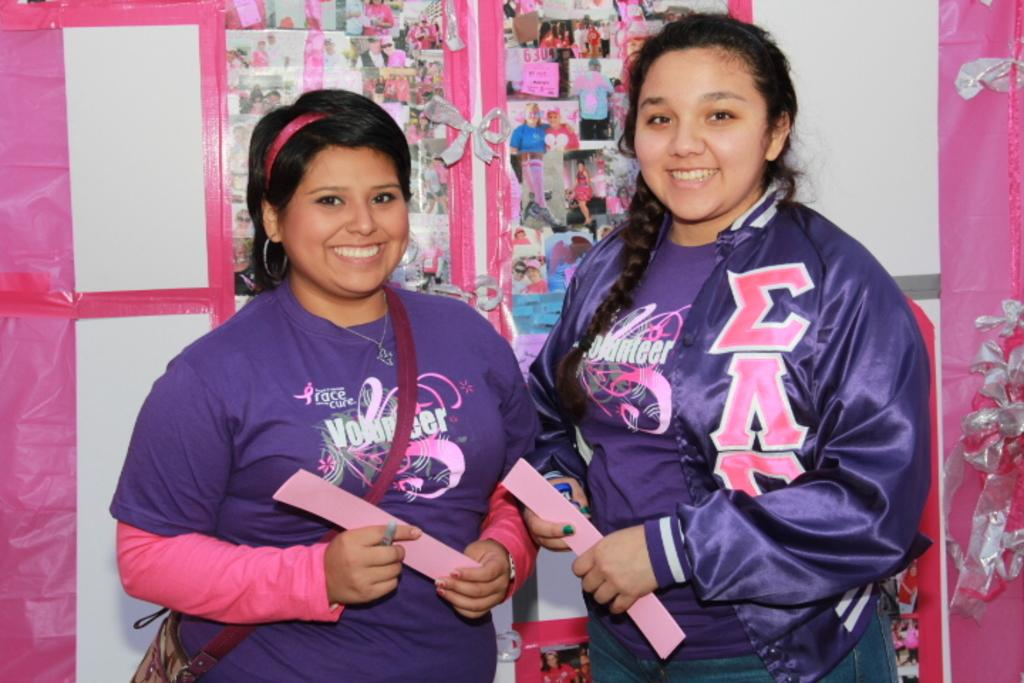<image>
Create a compact narrative representing the image presented. Two teen girls stand together wearing purple and pink shirts stating that they volunteered with Race for a Cure. 